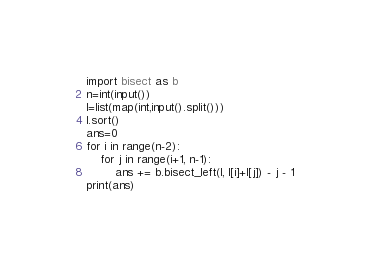<code> <loc_0><loc_0><loc_500><loc_500><_Python_>import bisect as b
n=int(input())
l=list(map(int,input().split()))
l.sort()
ans=0
for i in range(n-2):
    for j in range(i+1, n-1):
        ans += b.bisect_left(l, l[i]+l[j]) - j - 1
print(ans)</code> 